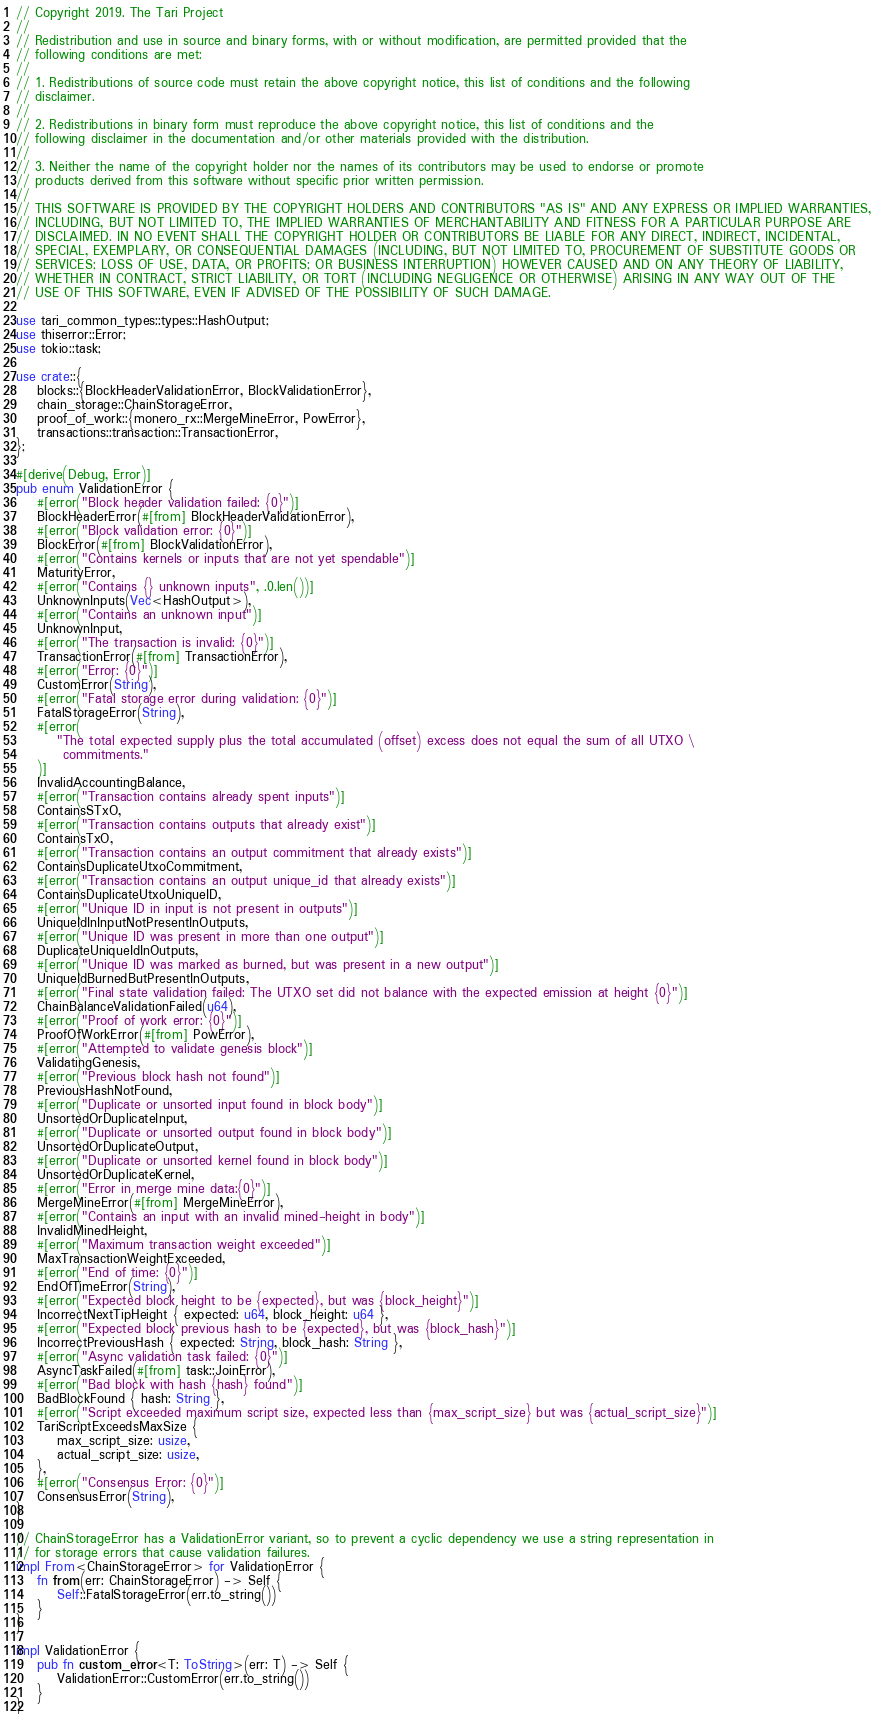Convert code to text. <code><loc_0><loc_0><loc_500><loc_500><_Rust_>// Copyright 2019. The Tari Project
//
// Redistribution and use in source and binary forms, with or without modification, are permitted provided that the
// following conditions are met:
//
// 1. Redistributions of source code must retain the above copyright notice, this list of conditions and the following
// disclaimer.
//
// 2. Redistributions in binary form must reproduce the above copyright notice, this list of conditions and the
// following disclaimer in the documentation and/or other materials provided with the distribution.
//
// 3. Neither the name of the copyright holder nor the names of its contributors may be used to endorse or promote
// products derived from this software without specific prior written permission.
//
// THIS SOFTWARE IS PROVIDED BY THE COPYRIGHT HOLDERS AND CONTRIBUTORS "AS IS" AND ANY EXPRESS OR IMPLIED WARRANTIES,
// INCLUDING, BUT NOT LIMITED TO, THE IMPLIED WARRANTIES OF MERCHANTABILITY AND FITNESS FOR A PARTICULAR PURPOSE ARE
// DISCLAIMED. IN NO EVENT SHALL THE COPYRIGHT HOLDER OR CONTRIBUTORS BE LIABLE FOR ANY DIRECT, INDIRECT, INCIDENTAL,
// SPECIAL, EXEMPLARY, OR CONSEQUENTIAL DAMAGES (INCLUDING, BUT NOT LIMITED TO, PROCUREMENT OF SUBSTITUTE GOODS OR
// SERVICES; LOSS OF USE, DATA, OR PROFITS; OR BUSINESS INTERRUPTION) HOWEVER CAUSED AND ON ANY THEORY OF LIABILITY,
// WHETHER IN CONTRACT, STRICT LIABILITY, OR TORT (INCLUDING NEGLIGENCE OR OTHERWISE) ARISING IN ANY WAY OUT OF THE
// USE OF THIS SOFTWARE, EVEN IF ADVISED OF THE POSSIBILITY OF SUCH DAMAGE.

use tari_common_types::types::HashOutput;
use thiserror::Error;
use tokio::task;

use crate::{
    blocks::{BlockHeaderValidationError, BlockValidationError},
    chain_storage::ChainStorageError,
    proof_of_work::{monero_rx::MergeMineError, PowError},
    transactions::transaction::TransactionError,
};

#[derive(Debug, Error)]
pub enum ValidationError {
    #[error("Block header validation failed: {0}")]
    BlockHeaderError(#[from] BlockHeaderValidationError),
    #[error("Block validation error: {0}")]
    BlockError(#[from] BlockValidationError),
    #[error("Contains kernels or inputs that are not yet spendable")]
    MaturityError,
    #[error("Contains {} unknown inputs", .0.len())]
    UnknownInputs(Vec<HashOutput>),
    #[error("Contains an unknown input")]
    UnknownInput,
    #[error("The transaction is invalid: {0}")]
    TransactionError(#[from] TransactionError),
    #[error("Error: {0}")]
    CustomError(String),
    #[error("Fatal storage error during validation: {0}")]
    FatalStorageError(String),
    #[error(
        "The total expected supply plus the total accumulated (offset) excess does not equal the sum of all UTXO \
         commitments."
    )]
    InvalidAccountingBalance,
    #[error("Transaction contains already spent inputs")]
    ContainsSTxO,
    #[error("Transaction contains outputs that already exist")]
    ContainsTxO,
    #[error("Transaction contains an output commitment that already exists")]
    ContainsDuplicateUtxoCommitment,
    #[error("Transaction contains an output unique_id that already exists")]
    ContainsDuplicateUtxoUniqueID,
    #[error("Unique ID in input is not present in outputs")]
    UniqueIdInInputNotPresentInOutputs,
    #[error("Unique ID was present in more than one output")]
    DuplicateUniqueIdInOutputs,
    #[error("Unique ID was marked as burned, but was present in a new output")]
    UniqueIdBurnedButPresentInOutputs,
    #[error("Final state validation failed: The UTXO set did not balance with the expected emission at height {0}")]
    ChainBalanceValidationFailed(u64),
    #[error("Proof of work error: {0}")]
    ProofOfWorkError(#[from] PowError),
    #[error("Attempted to validate genesis block")]
    ValidatingGenesis,
    #[error("Previous block hash not found")]
    PreviousHashNotFound,
    #[error("Duplicate or unsorted input found in block body")]
    UnsortedOrDuplicateInput,
    #[error("Duplicate or unsorted output found in block body")]
    UnsortedOrDuplicateOutput,
    #[error("Duplicate or unsorted kernel found in block body")]
    UnsortedOrDuplicateKernel,
    #[error("Error in merge mine data:{0}")]
    MergeMineError(#[from] MergeMineError),
    #[error("Contains an input with an invalid mined-height in body")]
    InvalidMinedHeight,
    #[error("Maximum transaction weight exceeded")]
    MaxTransactionWeightExceeded,
    #[error("End of time: {0}")]
    EndOfTimeError(String),
    #[error("Expected block height to be {expected}, but was {block_height}")]
    IncorrectNextTipHeight { expected: u64, block_height: u64 },
    #[error("Expected block previous hash to be {expected}, but was {block_hash}")]
    IncorrectPreviousHash { expected: String, block_hash: String },
    #[error("Async validation task failed: {0}")]
    AsyncTaskFailed(#[from] task::JoinError),
    #[error("Bad block with hash {hash} found")]
    BadBlockFound { hash: String },
    #[error("Script exceeded maximum script size, expected less than {max_script_size} but was {actual_script_size}")]
    TariScriptExceedsMaxSize {
        max_script_size: usize,
        actual_script_size: usize,
    },
    #[error("Consensus Error: {0}")]
    ConsensusError(String),
}

// ChainStorageError has a ValidationError variant, so to prevent a cyclic dependency we use a string representation in
// for storage errors that cause validation failures.
impl From<ChainStorageError> for ValidationError {
    fn from(err: ChainStorageError) -> Self {
        Self::FatalStorageError(err.to_string())
    }
}

impl ValidationError {
    pub fn custom_error<T: ToString>(err: T) -> Self {
        ValidationError::CustomError(err.to_string())
    }
}
</code> 